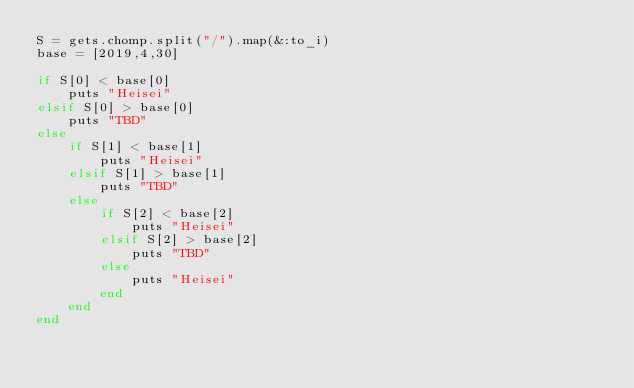Convert code to text. <code><loc_0><loc_0><loc_500><loc_500><_Ruby_>S = gets.chomp.split("/").map(&:to_i)
base = [2019,4,30]

if S[0] < base[0]
    puts "Heisei"
elsif S[0] > base[0]
    puts "TBD"
else
    if S[1] < base[1]
        puts "Heisei"
    elsif S[1] > base[1]
        puts "TBD"
    else
        if S[2] < base[2]
            puts "Heisei"
        elsif S[2] > base[2]
            puts "TBD"
        else
            puts "Heisei"
        end
    end
end
</code> 